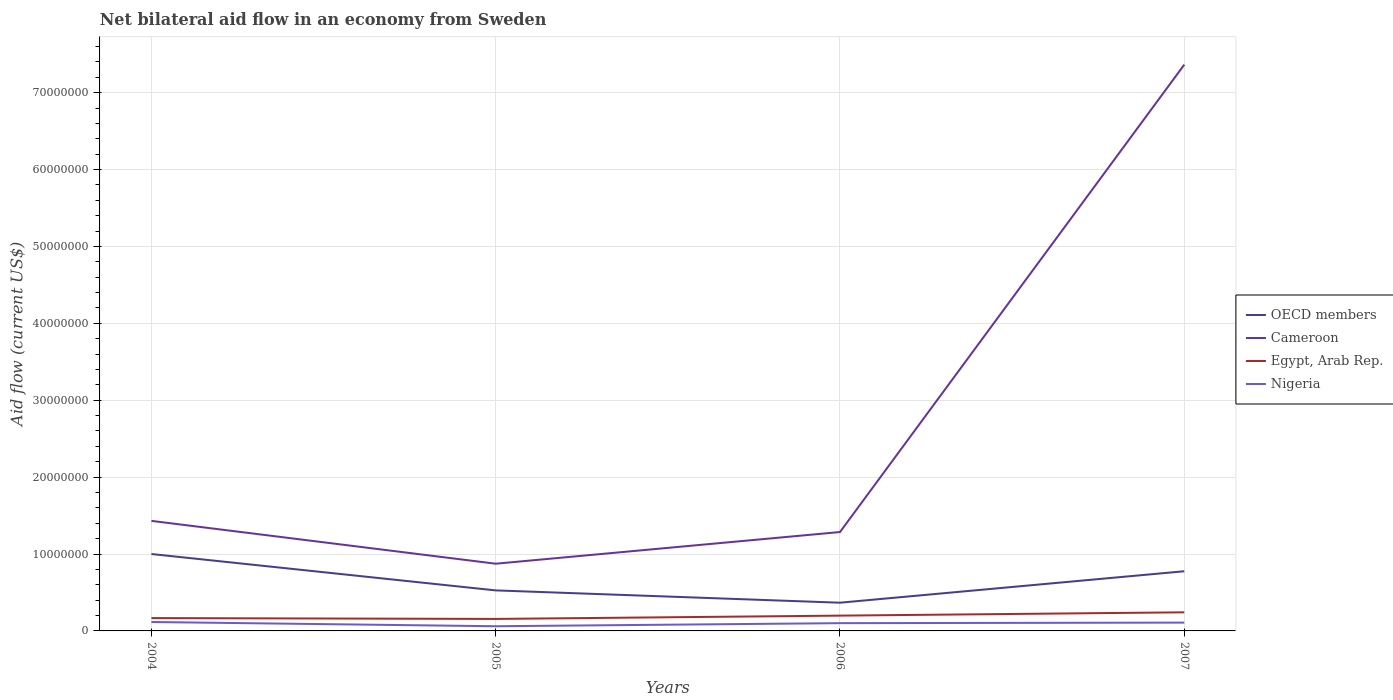How many different coloured lines are there?
Offer a terse response. 4. Across all years, what is the maximum net bilateral aid flow in OECD members?
Give a very brief answer. 3.67e+06. What is the total net bilateral aid flow in Cameroon in the graph?
Give a very brief answer. -5.93e+07. What is the difference between the highest and the second highest net bilateral aid flow in Cameroon?
Your answer should be very brief. 6.49e+07. What is the difference between the highest and the lowest net bilateral aid flow in OECD members?
Ensure brevity in your answer.  2. Is the net bilateral aid flow in Nigeria strictly greater than the net bilateral aid flow in Cameroon over the years?
Offer a very short reply. Yes. How many lines are there?
Keep it short and to the point. 4. Does the graph contain grids?
Offer a terse response. Yes. Where does the legend appear in the graph?
Keep it short and to the point. Center right. How are the legend labels stacked?
Make the answer very short. Vertical. What is the title of the graph?
Keep it short and to the point. Net bilateral aid flow in an economy from Sweden. Does "Somalia" appear as one of the legend labels in the graph?
Make the answer very short. No. What is the label or title of the Y-axis?
Give a very brief answer. Aid flow (current US$). What is the Aid flow (current US$) of OECD members in 2004?
Your answer should be very brief. 1.00e+07. What is the Aid flow (current US$) of Cameroon in 2004?
Make the answer very short. 1.43e+07. What is the Aid flow (current US$) in Egypt, Arab Rep. in 2004?
Your response must be concise. 1.67e+06. What is the Aid flow (current US$) of Nigeria in 2004?
Ensure brevity in your answer.  1.16e+06. What is the Aid flow (current US$) in OECD members in 2005?
Your answer should be compact. 5.27e+06. What is the Aid flow (current US$) of Cameroon in 2005?
Provide a succinct answer. 8.74e+06. What is the Aid flow (current US$) in Egypt, Arab Rep. in 2005?
Ensure brevity in your answer.  1.56e+06. What is the Aid flow (current US$) of Nigeria in 2005?
Your answer should be very brief. 6.10e+05. What is the Aid flow (current US$) of OECD members in 2006?
Ensure brevity in your answer.  3.67e+06. What is the Aid flow (current US$) of Cameroon in 2006?
Provide a short and direct response. 1.29e+07. What is the Aid flow (current US$) of Egypt, Arab Rep. in 2006?
Give a very brief answer. 1.99e+06. What is the Aid flow (current US$) of Nigeria in 2006?
Provide a succinct answer. 1.01e+06. What is the Aid flow (current US$) of OECD members in 2007?
Your answer should be very brief. 7.76e+06. What is the Aid flow (current US$) of Cameroon in 2007?
Provide a succinct answer. 7.36e+07. What is the Aid flow (current US$) of Egypt, Arab Rep. in 2007?
Offer a very short reply. 2.42e+06. What is the Aid flow (current US$) of Nigeria in 2007?
Make the answer very short. 1.08e+06. Across all years, what is the maximum Aid flow (current US$) in OECD members?
Offer a terse response. 1.00e+07. Across all years, what is the maximum Aid flow (current US$) of Cameroon?
Ensure brevity in your answer.  7.36e+07. Across all years, what is the maximum Aid flow (current US$) of Egypt, Arab Rep.?
Offer a terse response. 2.42e+06. Across all years, what is the maximum Aid flow (current US$) of Nigeria?
Keep it short and to the point. 1.16e+06. Across all years, what is the minimum Aid flow (current US$) in OECD members?
Your response must be concise. 3.67e+06. Across all years, what is the minimum Aid flow (current US$) of Cameroon?
Give a very brief answer. 8.74e+06. Across all years, what is the minimum Aid flow (current US$) in Egypt, Arab Rep.?
Provide a short and direct response. 1.56e+06. What is the total Aid flow (current US$) in OECD members in the graph?
Offer a very short reply. 2.67e+07. What is the total Aid flow (current US$) in Cameroon in the graph?
Your answer should be compact. 1.10e+08. What is the total Aid flow (current US$) in Egypt, Arab Rep. in the graph?
Your answer should be compact. 7.64e+06. What is the total Aid flow (current US$) of Nigeria in the graph?
Your response must be concise. 3.86e+06. What is the difference between the Aid flow (current US$) in OECD members in 2004 and that in 2005?
Your response must be concise. 4.73e+06. What is the difference between the Aid flow (current US$) in Cameroon in 2004 and that in 2005?
Keep it short and to the point. 5.57e+06. What is the difference between the Aid flow (current US$) in Egypt, Arab Rep. in 2004 and that in 2005?
Provide a succinct answer. 1.10e+05. What is the difference between the Aid flow (current US$) in Nigeria in 2004 and that in 2005?
Keep it short and to the point. 5.50e+05. What is the difference between the Aid flow (current US$) in OECD members in 2004 and that in 2006?
Make the answer very short. 6.33e+06. What is the difference between the Aid flow (current US$) of Cameroon in 2004 and that in 2006?
Offer a terse response. 1.45e+06. What is the difference between the Aid flow (current US$) in Egypt, Arab Rep. in 2004 and that in 2006?
Ensure brevity in your answer.  -3.20e+05. What is the difference between the Aid flow (current US$) in OECD members in 2004 and that in 2007?
Offer a very short reply. 2.24e+06. What is the difference between the Aid flow (current US$) of Cameroon in 2004 and that in 2007?
Your answer should be compact. -5.93e+07. What is the difference between the Aid flow (current US$) of Egypt, Arab Rep. in 2004 and that in 2007?
Your response must be concise. -7.50e+05. What is the difference between the Aid flow (current US$) in Nigeria in 2004 and that in 2007?
Your response must be concise. 8.00e+04. What is the difference between the Aid flow (current US$) in OECD members in 2005 and that in 2006?
Ensure brevity in your answer.  1.60e+06. What is the difference between the Aid flow (current US$) of Cameroon in 2005 and that in 2006?
Offer a terse response. -4.12e+06. What is the difference between the Aid flow (current US$) in Egypt, Arab Rep. in 2005 and that in 2006?
Provide a short and direct response. -4.30e+05. What is the difference between the Aid flow (current US$) in Nigeria in 2005 and that in 2006?
Provide a succinct answer. -4.00e+05. What is the difference between the Aid flow (current US$) of OECD members in 2005 and that in 2007?
Provide a succinct answer. -2.49e+06. What is the difference between the Aid flow (current US$) in Cameroon in 2005 and that in 2007?
Offer a terse response. -6.49e+07. What is the difference between the Aid flow (current US$) of Egypt, Arab Rep. in 2005 and that in 2007?
Provide a succinct answer. -8.60e+05. What is the difference between the Aid flow (current US$) of Nigeria in 2005 and that in 2007?
Keep it short and to the point. -4.70e+05. What is the difference between the Aid flow (current US$) in OECD members in 2006 and that in 2007?
Your response must be concise. -4.09e+06. What is the difference between the Aid flow (current US$) of Cameroon in 2006 and that in 2007?
Make the answer very short. -6.08e+07. What is the difference between the Aid flow (current US$) of Egypt, Arab Rep. in 2006 and that in 2007?
Your answer should be very brief. -4.30e+05. What is the difference between the Aid flow (current US$) in OECD members in 2004 and the Aid flow (current US$) in Cameroon in 2005?
Make the answer very short. 1.26e+06. What is the difference between the Aid flow (current US$) in OECD members in 2004 and the Aid flow (current US$) in Egypt, Arab Rep. in 2005?
Ensure brevity in your answer.  8.44e+06. What is the difference between the Aid flow (current US$) in OECD members in 2004 and the Aid flow (current US$) in Nigeria in 2005?
Keep it short and to the point. 9.39e+06. What is the difference between the Aid flow (current US$) of Cameroon in 2004 and the Aid flow (current US$) of Egypt, Arab Rep. in 2005?
Provide a succinct answer. 1.28e+07. What is the difference between the Aid flow (current US$) in Cameroon in 2004 and the Aid flow (current US$) in Nigeria in 2005?
Ensure brevity in your answer.  1.37e+07. What is the difference between the Aid flow (current US$) of Egypt, Arab Rep. in 2004 and the Aid flow (current US$) of Nigeria in 2005?
Ensure brevity in your answer.  1.06e+06. What is the difference between the Aid flow (current US$) in OECD members in 2004 and the Aid flow (current US$) in Cameroon in 2006?
Offer a very short reply. -2.86e+06. What is the difference between the Aid flow (current US$) of OECD members in 2004 and the Aid flow (current US$) of Egypt, Arab Rep. in 2006?
Provide a succinct answer. 8.01e+06. What is the difference between the Aid flow (current US$) of OECD members in 2004 and the Aid flow (current US$) of Nigeria in 2006?
Ensure brevity in your answer.  8.99e+06. What is the difference between the Aid flow (current US$) in Cameroon in 2004 and the Aid flow (current US$) in Egypt, Arab Rep. in 2006?
Your answer should be compact. 1.23e+07. What is the difference between the Aid flow (current US$) of Cameroon in 2004 and the Aid flow (current US$) of Nigeria in 2006?
Offer a very short reply. 1.33e+07. What is the difference between the Aid flow (current US$) in Egypt, Arab Rep. in 2004 and the Aid flow (current US$) in Nigeria in 2006?
Your response must be concise. 6.60e+05. What is the difference between the Aid flow (current US$) in OECD members in 2004 and the Aid flow (current US$) in Cameroon in 2007?
Your answer should be very brief. -6.36e+07. What is the difference between the Aid flow (current US$) in OECD members in 2004 and the Aid flow (current US$) in Egypt, Arab Rep. in 2007?
Your response must be concise. 7.58e+06. What is the difference between the Aid flow (current US$) in OECD members in 2004 and the Aid flow (current US$) in Nigeria in 2007?
Your answer should be compact. 8.92e+06. What is the difference between the Aid flow (current US$) in Cameroon in 2004 and the Aid flow (current US$) in Egypt, Arab Rep. in 2007?
Keep it short and to the point. 1.19e+07. What is the difference between the Aid flow (current US$) of Cameroon in 2004 and the Aid flow (current US$) of Nigeria in 2007?
Your answer should be compact. 1.32e+07. What is the difference between the Aid flow (current US$) of Egypt, Arab Rep. in 2004 and the Aid flow (current US$) of Nigeria in 2007?
Offer a terse response. 5.90e+05. What is the difference between the Aid flow (current US$) of OECD members in 2005 and the Aid flow (current US$) of Cameroon in 2006?
Give a very brief answer. -7.59e+06. What is the difference between the Aid flow (current US$) in OECD members in 2005 and the Aid flow (current US$) in Egypt, Arab Rep. in 2006?
Give a very brief answer. 3.28e+06. What is the difference between the Aid flow (current US$) of OECD members in 2005 and the Aid flow (current US$) of Nigeria in 2006?
Ensure brevity in your answer.  4.26e+06. What is the difference between the Aid flow (current US$) of Cameroon in 2005 and the Aid flow (current US$) of Egypt, Arab Rep. in 2006?
Your answer should be compact. 6.75e+06. What is the difference between the Aid flow (current US$) of Cameroon in 2005 and the Aid flow (current US$) of Nigeria in 2006?
Provide a short and direct response. 7.73e+06. What is the difference between the Aid flow (current US$) in Egypt, Arab Rep. in 2005 and the Aid flow (current US$) in Nigeria in 2006?
Your answer should be very brief. 5.50e+05. What is the difference between the Aid flow (current US$) of OECD members in 2005 and the Aid flow (current US$) of Cameroon in 2007?
Offer a very short reply. -6.84e+07. What is the difference between the Aid flow (current US$) of OECD members in 2005 and the Aid flow (current US$) of Egypt, Arab Rep. in 2007?
Provide a succinct answer. 2.85e+06. What is the difference between the Aid flow (current US$) of OECD members in 2005 and the Aid flow (current US$) of Nigeria in 2007?
Make the answer very short. 4.19e+06. What is the difference between the Aid flow (current US$) of Cameroon in 2005 and the Aid flow (current US$) of Egypt, Arab Rep. in 2007?
Your answer should be compact. 6.32e+06. What is the difference between the Aid flow (current US$) in Cameroon in 2005 and the Aid flow (current US$) in Nigeria in 2007?
Offer a very short reply. 7.66e+06. What is the difference between the Aid flow (current US$) in OECD members in 2006 and the Aid flow (current US$) in Cameroon in 2007?
Your answer should be compact. -7.00e+07. What is the difference between the Aid flow (current US$) in OECD members in 2006 and the Aid flow (current US$) in Egypt, Arab Rep. in 2007?
Offer a very short reply. 1.25e+06. What is the difference between the Aid flow (current US$) in OECD members in 2006 and the Aid flow (current US$) in Nigeria in 2007?
Your answer should be compact. 2.59e+06. What is the difference between the Aid flow (current US$) of Cameroon in 2006 and the Aid flow (current US$) of Egypt, Arab Rep. in 2007?
Give a very brief answer. 1.04e+07. What is the difference between the Aid flow (current US$) of Cameroon in 2006 and the Aid flow (current US$) of Nigeria in 2007?
Make the answer very short. 1.18e+07. What is the difference between the Aid flow (current US$) in Egypt, Arab Rep. in 2006 and the Aid flow (current US$) in Nigeria in 2007?
Your answer should be compact. 9.10e+05. What is the average Aid flow (current US$) in OECD members per year?
Provide a succinct answer. 6.68e+06. What is the average Aid flow (current US$) in Cameroon per year?
Your response must be concise. 2.74e+07. What is the average Aid flow (current US$) in Egypt, Arab Rep. per year?
Offer a terse response. 1.91e+06. What is the average Aid flow (current US$) of Nigeria per year?
Keep it short and to the point. 9.65e+05. In the year 2004, what is the difference between the Aid flow (current US$) in OECD members and Aid flow (current US$) in Cameroon?
Ensure brevity in your answer.  -4.31e+06. In the year 2004, what is the difference between the Aid flow (current US$) of OECD members and Aid flow (current US$) of Egypt, Arab Rep.?
Offer a very short reply. 8.33e+06. In the year 2004, what is the difference between the Aid flow (current US$) of OECD members and Aid flow (current US$) of Nigeria?
Provide a short and direct response. 8.84e+06. In the year 2004, what is the difference between the Aid flow (current US$) in Cameroon and Aid flow (current US$) in Egypt, Arab Rep.?
Offer a terse response. 1.26e+07. In the year 2004, what is the difference between the Aid flow (current US$) of Cameroon and Aid flow (current US$) of Nigeria?
Keep it short and to the point. 1.32e+07. In the year 2004, what is the difference between the Aid flow (current US$) in Egypt, Arab Rep. and Aid flow (current US$) in Nigeria?
Offer a very short reply. 5.10e+05. In the year 2005, what is the difference between the Aid flow (current US$) in OECD members and Aid flow (current US$) in Cameroon?
Your answer should be very brief. -3.47e+06. In the year 2005, what is the difference between the Aid flow (current US$) in OECD members and Aid flow (current US$) in Egypt, Arab Rep.?
Keep it short and to the point. 3.71e+06. In the year 2005, what is the difference between the Aid flow (current US$) of OECD members and Aid flow (current US$) of Nigeria?
Your answer should be very brief. 4.66e+06. In the year 2005, what is the difference between the Aid flow (current US$) in Cameroon and Aid flow (current US$) in Egypt, Arab Rep.?
Your answer should be very brief. 7.18e+06. In the year 2005, what is the difference between the Aid flow (current US$) in Cameroon and Aid flow (current US$) in Nigeria?
Offer a terse response. 8.13e+06. In the year 2005, what is the difference between the Aid flow (current US$) in Egypt, Arab Rep. and Aid flow (current US$) in Nigeria?
Offer a very short reply. 9.50e+05. In the year 2006, what is the difference between the Aid flow (current US$) of OECD members and Aid flow (current US$) of Cameroon?
Your answer should be compact. -9.19e+06. In the year 2006, what is the difference between the Aid flow (current US$) in OECD members and Aid flow (current US$) in Egypt, Arab Rep.?
Keep it short and to the point. 1.68e+06. In the year 2006, what is the difference between the Aid flow (current US$) in OECD members and Aid flow (current US$) in Nigeria?
Keep it short and to the point. 2.66e+06. In the year 2006, what is the difference between the Aid flow (current US$) in Cameroon and Aid flow (current US$) in Egypt, Arab Rep.?
Your answer should be very brief. 1.09e+07. In the year 2006, what is the difference between the Aid flow (current US$) of Cameroon and Aid flow (current US$) of Nigeria?
Offer a terse response. 1.18e+07. In the year 2006, what is the difference between the Aid flow (current US$) in Egypt, Arab Rep. and Aid flow (current US$) in Nigeria?
Keep it short and to the point. 9.80e+05. In the year 2007, what is the difference between the Aid flow (current US$) in OECD members and Aid flow (current US$) in Cameroon?
Offer a very short reply. -6.59e+07. In the year 2007, what is the difference between the Aid flow (current US$) in OECD members and Aid flow (current US$) in Egypt, Arab Rep.?
Offer a very short reply. 5.34e+06. In the year 2007, what is the difference between the Aid flow (current US$) in OECD members and Aid flow (current US$) in Nigeria?
Ensure brevity in your answer.  6.68e+06. In the year 2007, what is the difference between the Aid flow (current US$) of Cameroon and Aid flow (current US$) of Egypt, Arab Rep.?
Give a very brief answer. 7.12e+07. In the year 2007, what is the difference between the Aid flow (current US$) of Cameroon and Aid flow (current US$) of Nigeria?
Offer a terse response. 7.26e+07. In the year 2007, what is the difference between the Aid flow (current US$) in Egypt, Arab Rep. and Aid flow (current US$) in Nigeria?
Make the answer very short. 1.34e+06. What is the ratio of the Aid flow (current US$) of OECD members in 2004 to that in 2005?
Offer a very short reply. 1.9. What is the ratio of the Aid flow (current US$) of Cameroon in 2004 to that in 2005?
Provide a succinct answer. 1.64. What is the ratio of the Aid flow (current US$) in Egypt, Arab Rep. in 2004 to that in 2005?
Offer a terse response. 1.07. What is the ratio of the Aid flow (current US$) in Nigeria in 2004 to that in 2005?
Offer a terse response. 1.9. What is the ratio of the Aid flow (current US$) in OECD members in 2004 to that in 2006?
Offer a very short reply. 2.72. What is the ratio of the Aid flow (current US$) in Cameroon in 2004 to that in 2006?
Your response must be concise. 1.11. What is the ratio of the Aid flow (current US$) of Egypt, Arab Rep. in 2004 to that in 2006?
Keep it short and to the point. 0.84. What is the ratio of the Aid flow (current US$) in Nigeria in 2004 to that in 2006?
Your answer should be very brief. 1.15. What is the ratio of the Aid flow (current US$) in OECD members in 2004 to that in 2007?
Give a very brief answer. 1.29. What is the ratio of the Aid flow (current US$) of Cameroon in 2004 to that in 2007?
Your response must be concise. 0.19. What is the ratio of the Aid flow (current US$) in Egypt, Arab Rep. in 2004 to that in 2007?
Provide a short and direct response. 0.69. What is the ratio of the Aid flow (current US$) of Nigeria in 2004 to that in 2007?
Ensure brevity in your answer.  1.07. What is the ratio of the Aid flow (current US$) of OECD members in 2005 to that in 2006?
Provide a short and direct response. 1.44. What is the ratio of the Aid flow (current US$) in Cameroon in 2005 to that in 2006?
Your answer should be very brief. 0.68. What is the ratio of the Aid flow (current US$) in Egypt, Arab Rep. in 2005 to that in 2006?
Offer a terse response. 0.78. What is the ratio of the Aid flow (current US$) in Nigeria in 2005 to that in 2006?
Offer a terse response. 0.6. What is the ratio of the Aid flow (current US$) in OECD members in 2005 to that in 2007?
Your answer should be very brief. 0.68. What is the ratio of the Aid flow (current US$) of Cameroon in 2005 to that in 2007?
Make the answer very short. 0.12. What is the ratio of the Aid flow (current US$) of Egypt, Arab Rep. in 2005 to that in 2007?
Give a very brief answer. 0.64. What is the ratio of the Aid flow (current US$) in Nigeria in 2005 to that in 2007?
Provide a short and direct response. 0.56. What is the ratio of the Aid flow (current US$) of OECD members in 2006 to that in 2007?
Provide a short and direct response. 0.47. What is the ratio of the Aid flow (current US$) of Cameroon in 2006 to that in 2007?
Offer a very short reply. 0.17. What is the ratio of the Aid flow (current US$) of Egypt, Arab Rep. in 2006 to that in 2007?
Provide a short and direct response. 0.82. What is the ratio of the Aid flow (current US$) of Nigeria in 2006 to that in 2007?
Offer a very short reply. 0.94. What is the difference between the highest and the second highest Aid flow (current US$) in OECD members?
Make the answer very short. 2.24e+06. What is the difference between the highest and the second highest Aid flow (current US$) in Cameroon?
Your answer should be very brief. 5.93e+07. What is the difference between the highest and the lowest Aid flow (current US$) in OECD members?
Keep it short and to the point. 6.33e+06. What is the difference between the highest and the lowest Aid flow (current US$) of Cameroon?
Offer a terse response. 6.49e+07. What is the difference between the highest and the lowest Aid flow (current US$) of Egypt, Arab Rep.?
Give a very brief answer. 8.60e+05. What is the difference between the highest and the lowest Aid flow (current US$) of Nigeria?
Provide a succinct answer. 5.50e+05. 